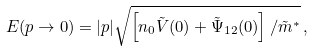<formula> <loc_0><loc_0><loc_500><loc_500>E ( p \to 0 ) = | p | \sqrt { \left [ n _ { 0 } \tilde { V } ( 0 ) + \tilde { \Psi } _ { 1 2 } ( 0 ) \right ] / \tilde { m } ^ { * } } \, ,</formula> 